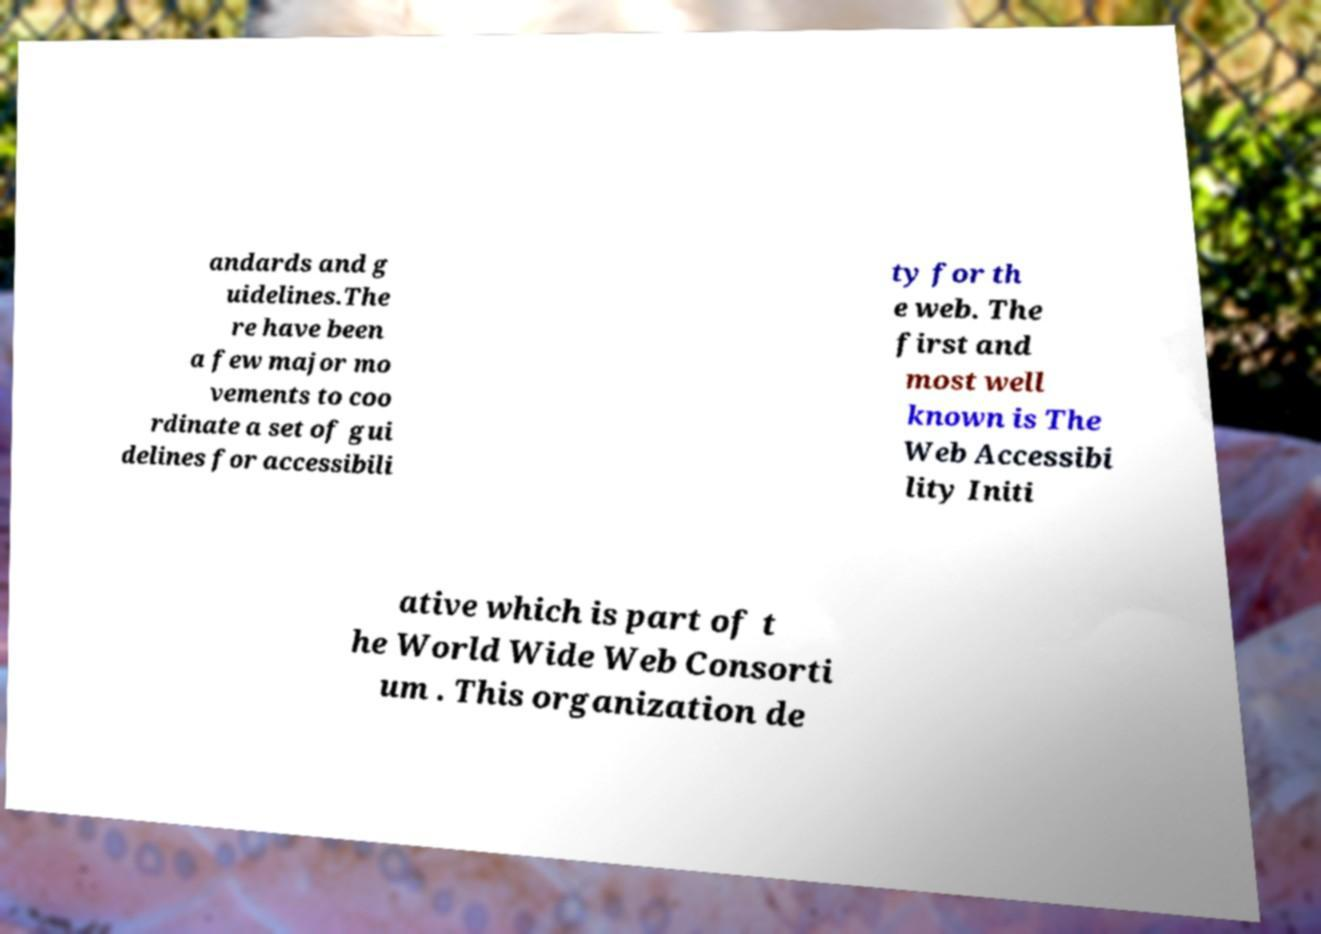For documentation purposes, I need the text within this image transcribed. Could you provide that? andards and g uidelines.The re have been a few major mo vements to coo rdinate a set of gui delines for accessibili ty for th e web. The first and most well known is The Web Accessibi lity Initi ative which is part of t he World Wide Web Consorti um . This organization de 